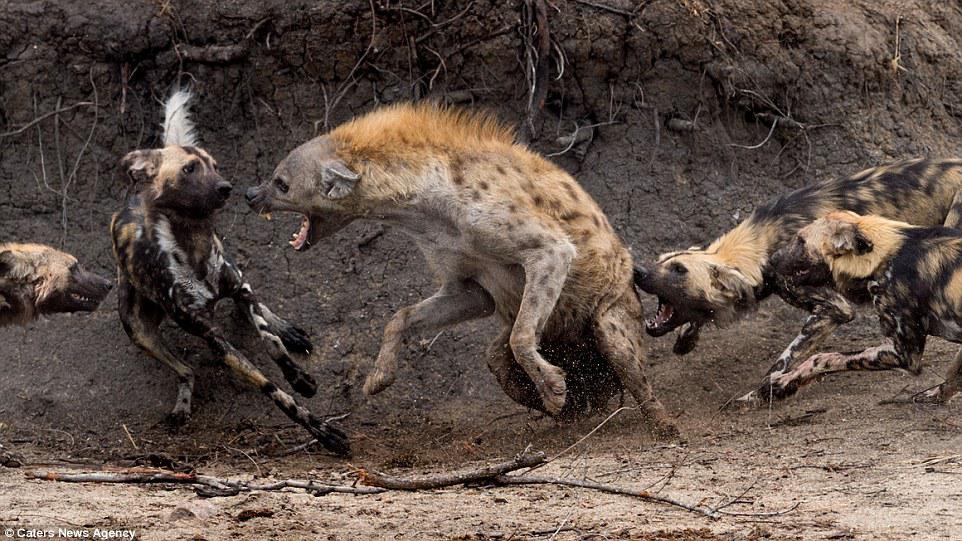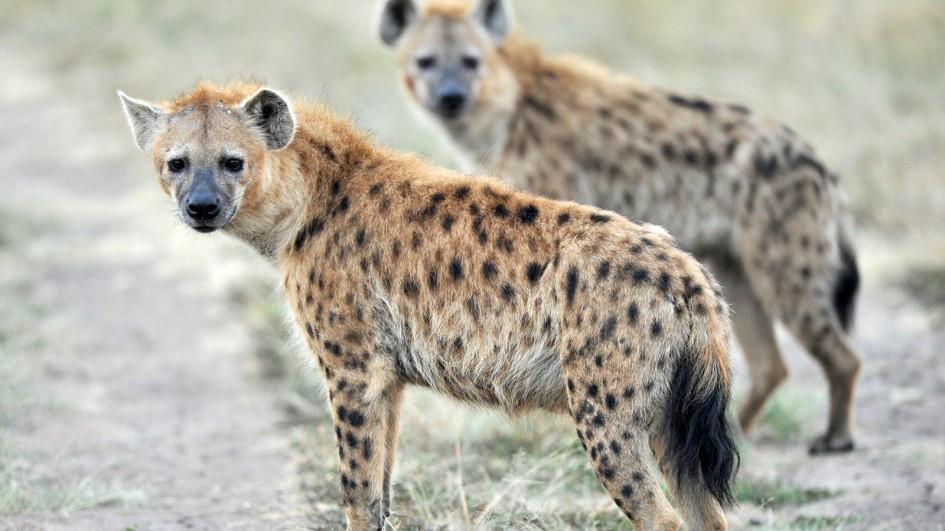The first image is the image on the left, the second image is the image on the right. Examine the images to the left and right. Is the description "Each image includes a hyena with a wide open mouth." accurate? Answer yes or no. No. 